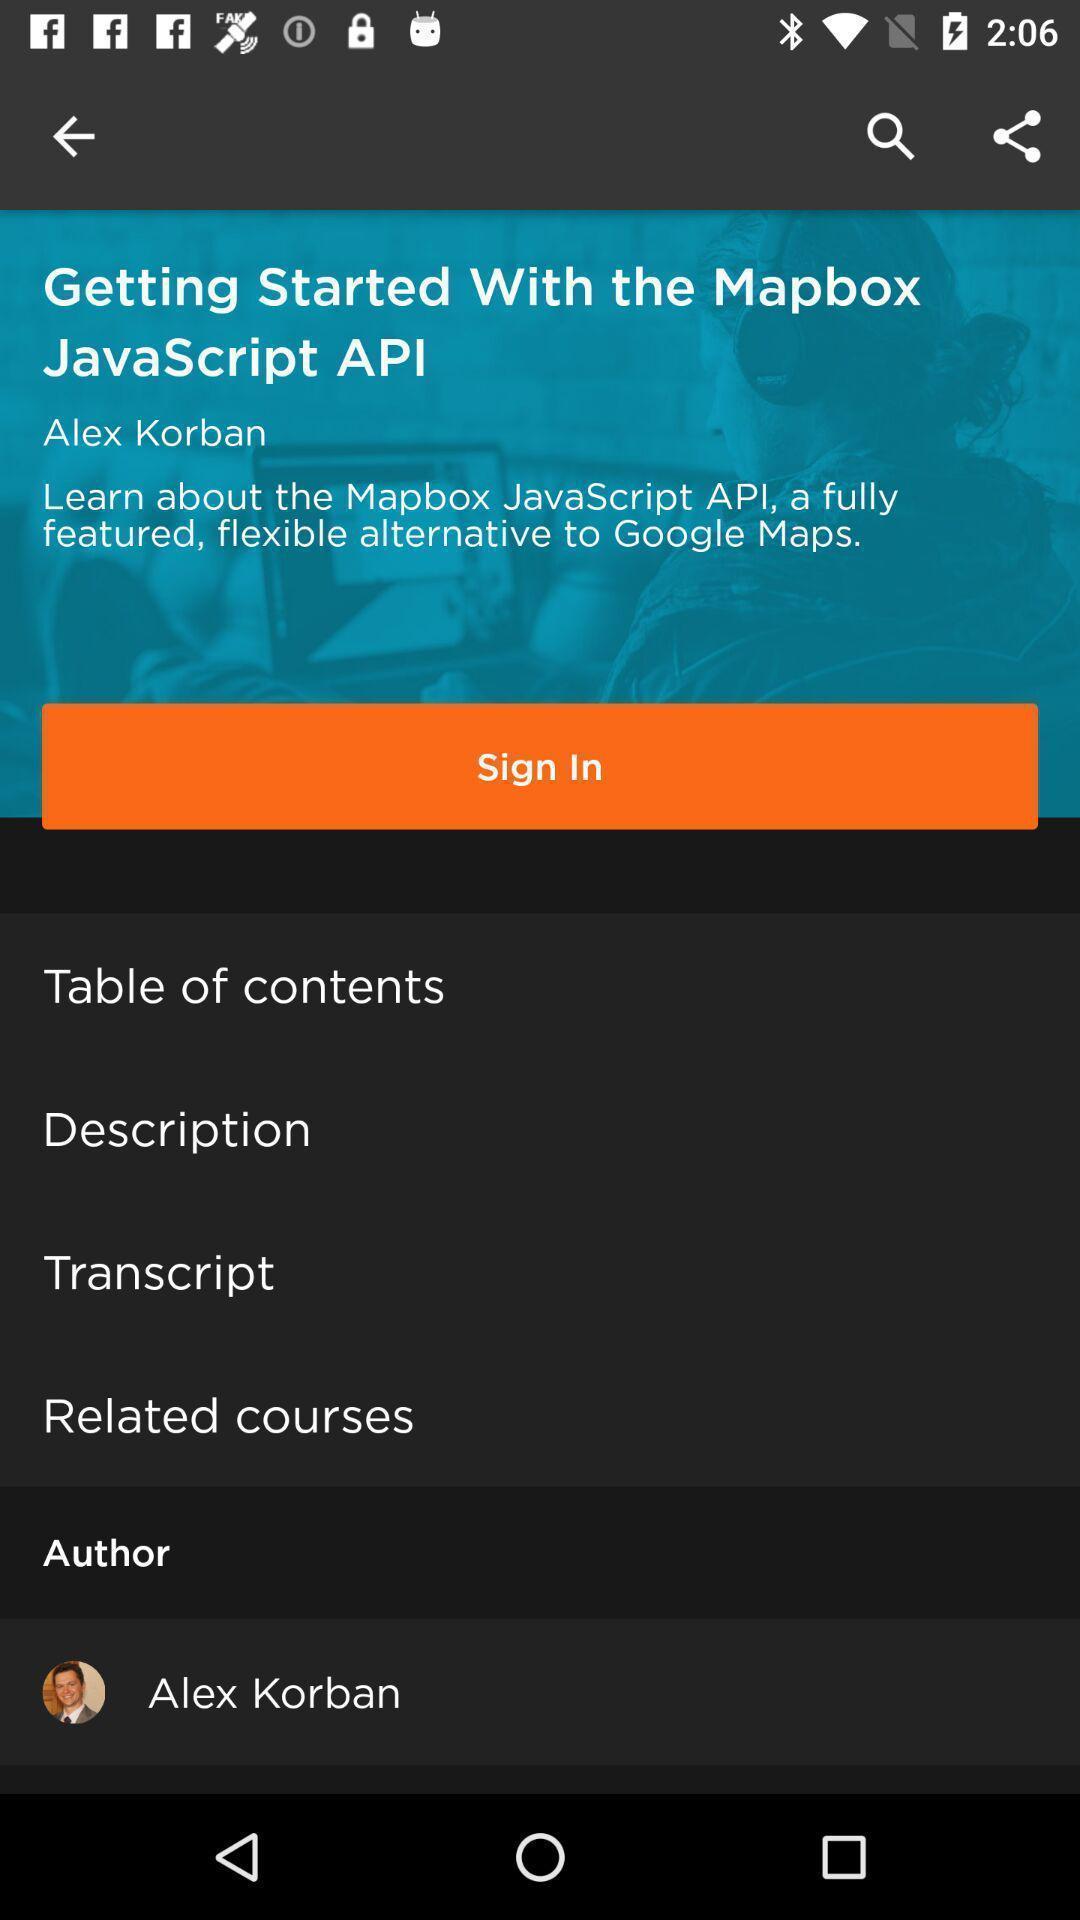Please provide a description for this image. Sign in page with different options in the learning app. 